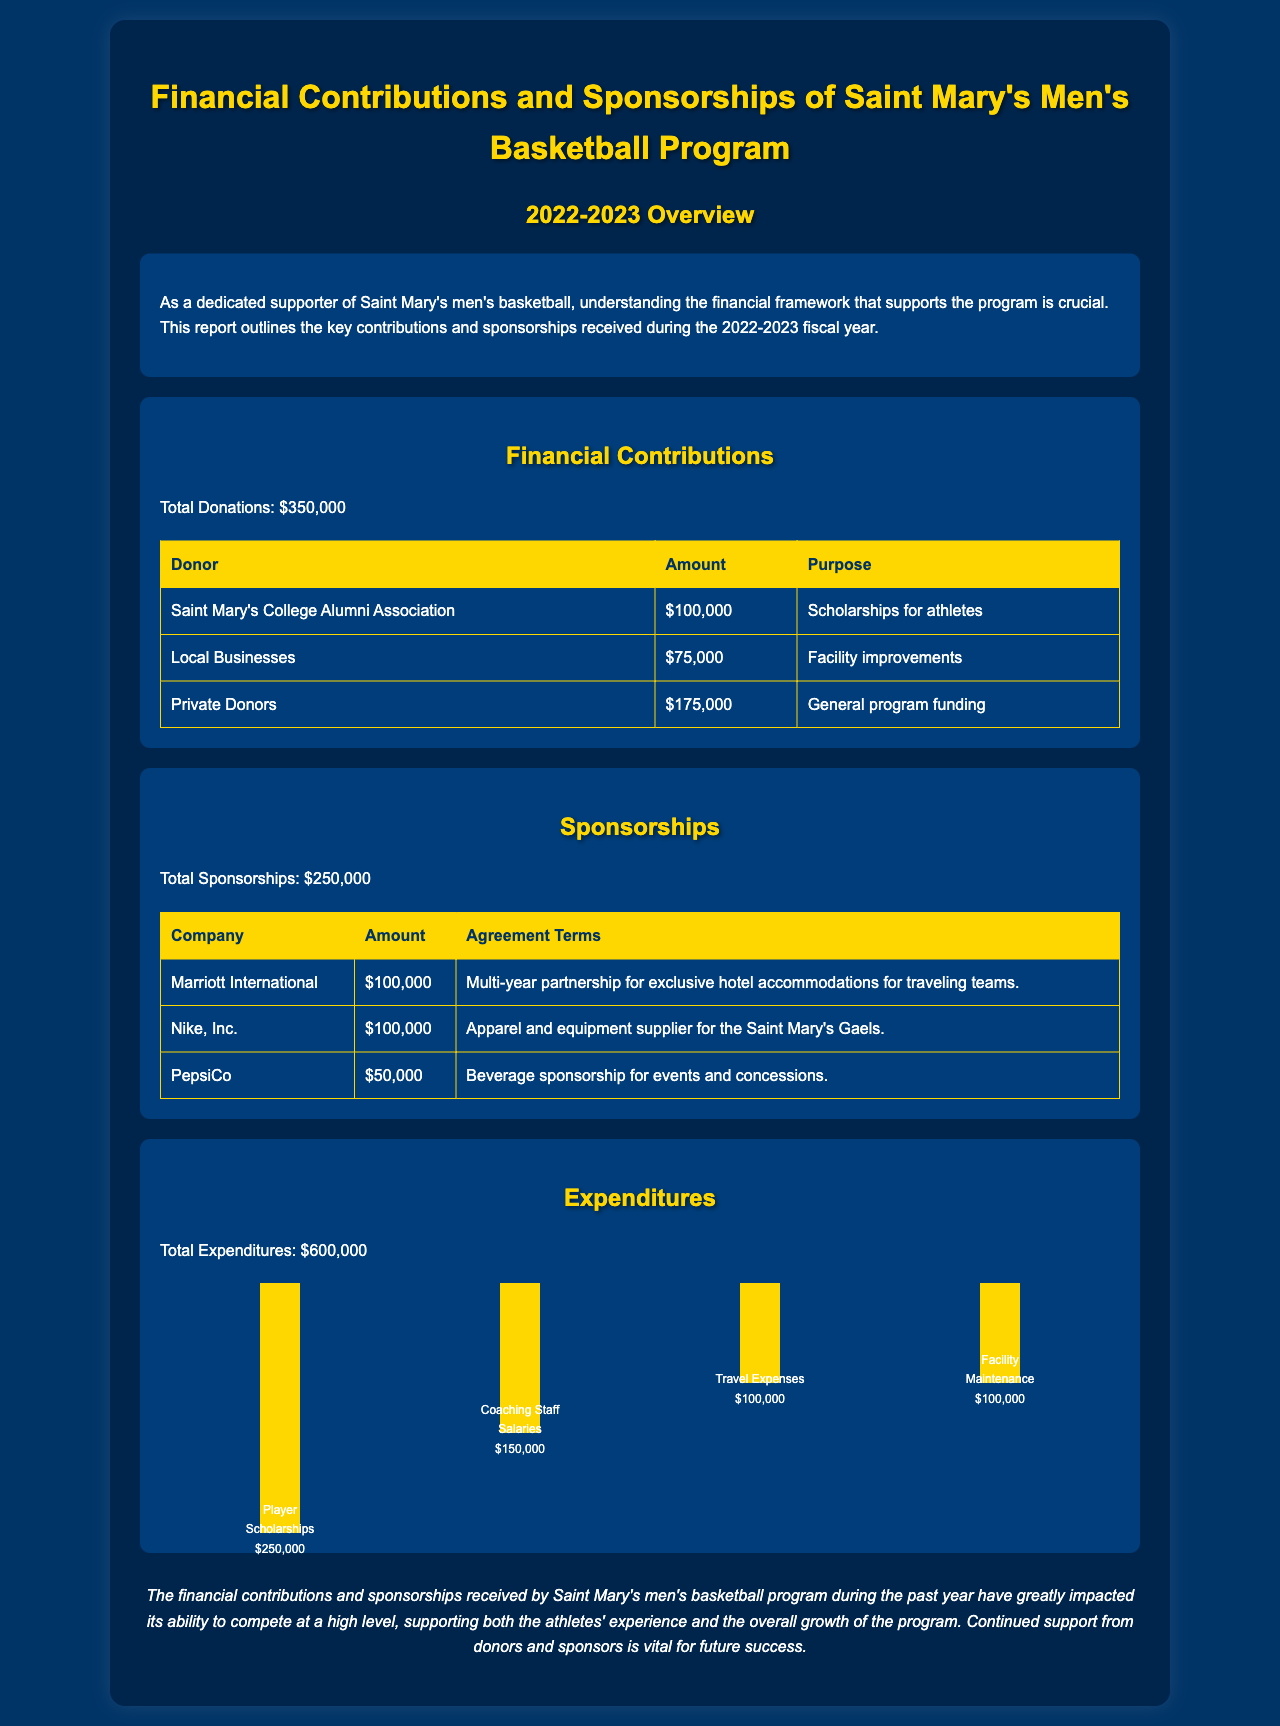What was the total amount of financial contributions for the 2022-2023 fiscal year? The total amount of financial contributions is listed directly in the report, which is $350,000.
Answer: $350,000 How much did the Private Donors contribute to the program? The contribution by Private Donors is specifically mentioned in the table under financial contributions, which is $175,000.
Answer: $175,000 What is the total amount of sponsorships mentioned in the report? The total amount of sponsorships is clearly stated in the document as $250,000.
Answer: $250,000 Which company provided the largest sponsorship amount? The company with the largest sponsorship amount is listed in the sponsorships table, which is Marriott International with $100,000.
Answer: Marriott International What is the purpose of the contribution from the Saint Mary's College Alumni Association? The purpose of this contribution is stated in the report, which is scholarships for athletes.
Answer: Scholarships for athletes What was the total expenditure for the 2022-2023 fiscal year? The total expenditure amount can be found in the report, which is $600,000.
Answer: $600,000 How much was allocated for player scholarships? The amount allocated for player scholarships is detailed in the expenditures section, which is $250,000.
Answer: $250,000 What are the agreement terms for Nike, Inc.? The agreement terms for Nike, Inc. are summarized in the sponsorships table as apparel and equipment supplier for the Saint Mary's Gaels.
Answer: Apparel and equipment supplier for the Saint Mary's Gaels What does the conclusion section emphasize about the financial contributions? The conclusion emphasizes the importance of continued support from donors and sponsors for the future success of the program.
Answer: Continued support from donors and sponsors is vital for future success 